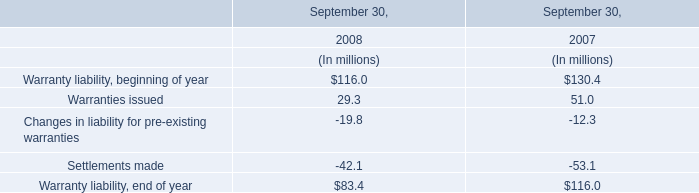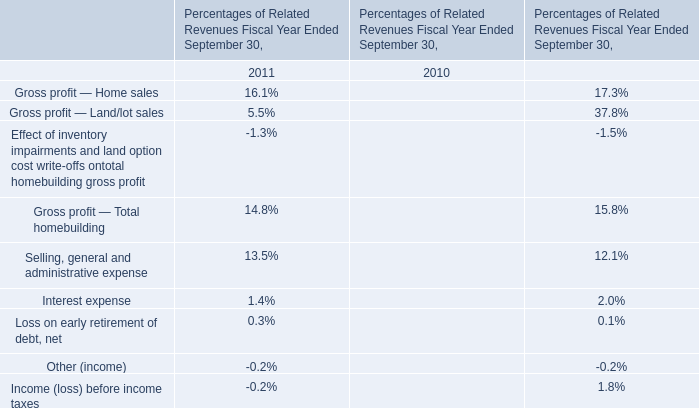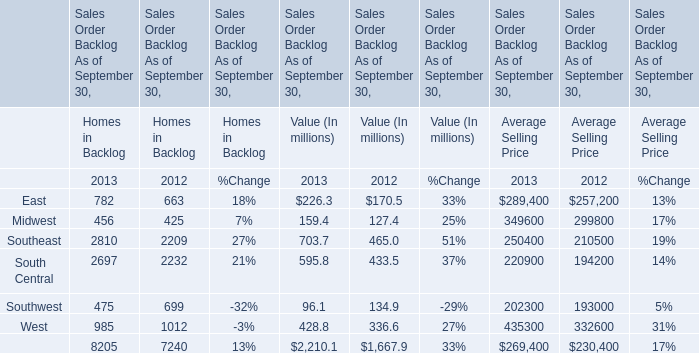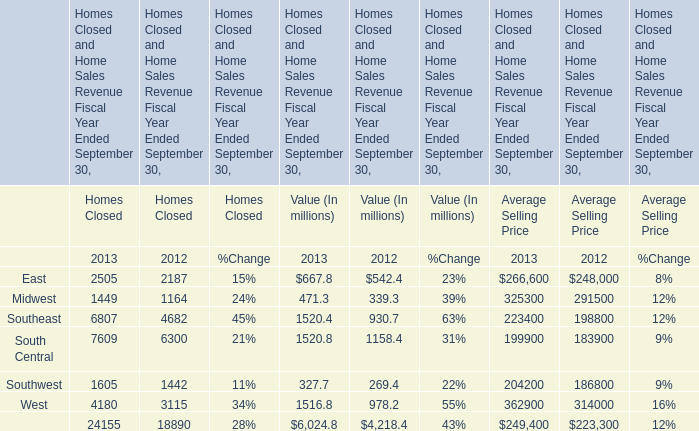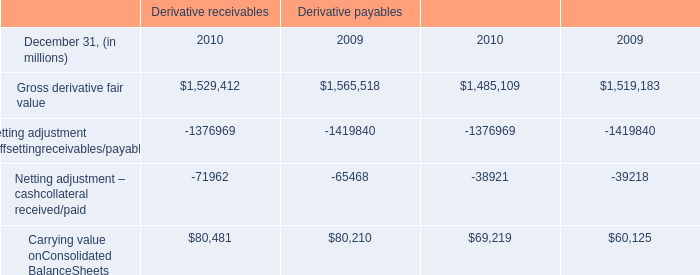for 2010 , how much in billions would the credit risk balance be reduced if the table considered all other collateral? 
Computations: (16.5 + 18.0)
Answer: 34.5. 